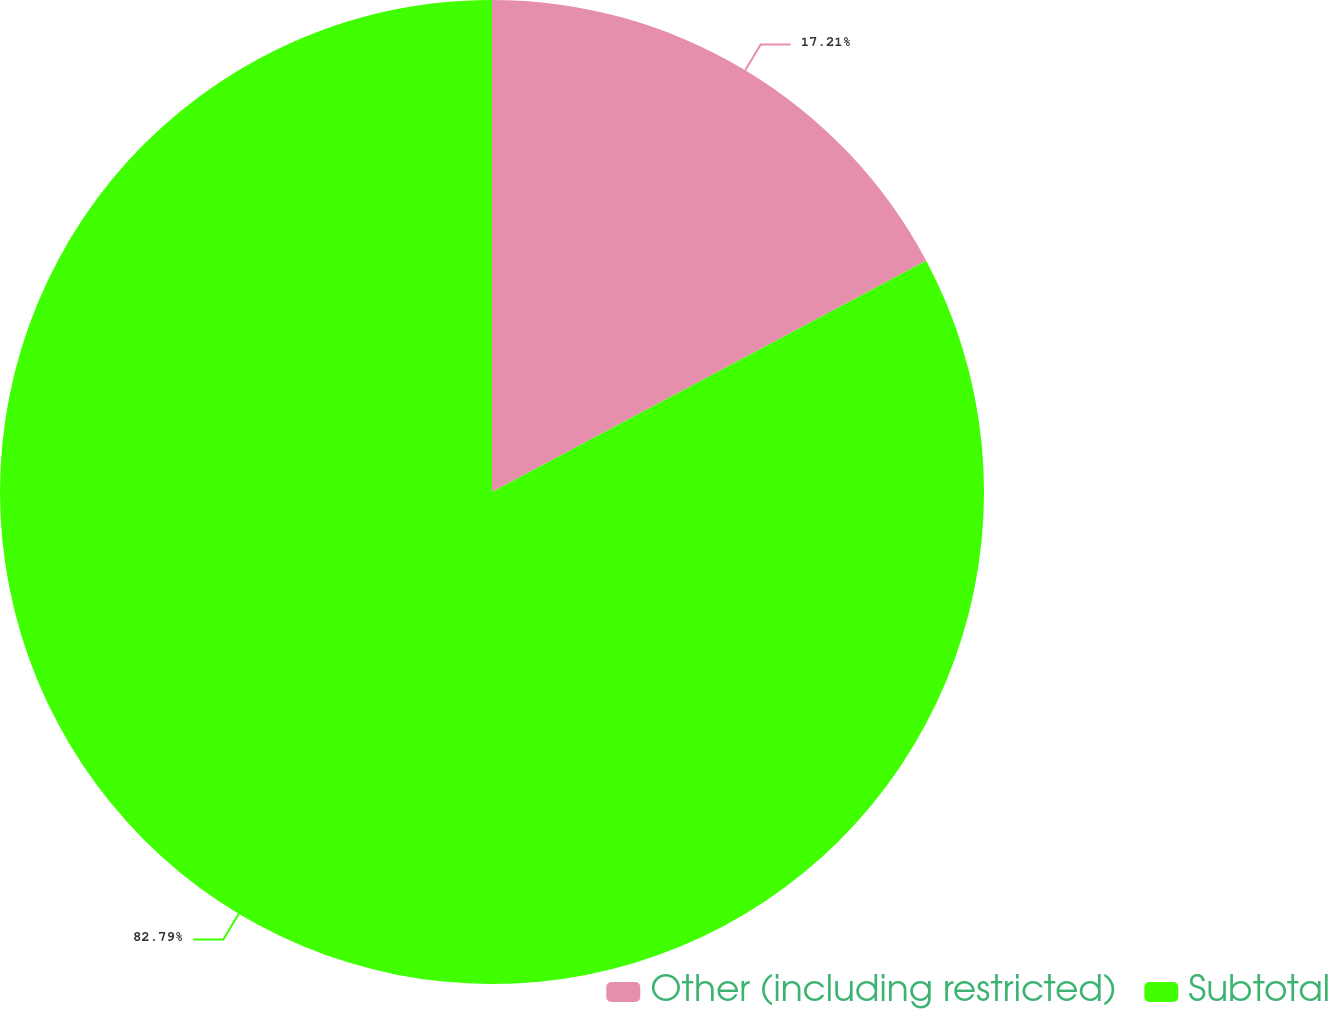<chart> <loc_0><loc_0><loc_500><loc_500><pie_chart><fcel>Other (including restricted)<fcel>Subtotal<nl><fcel>17.21%<fcel>82.79%<nl></chart> 